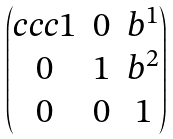Convert formula to latex. <formula><loc_0><loc_0><loc_500><loc_500>\begin{pmatrix} { c c c } 1 & 0 & b ^ { 1 } \\ 0 & 1 & b ^ { 2 } \\ 0 & 0 & 1 \end{pmatrix}</formula> 